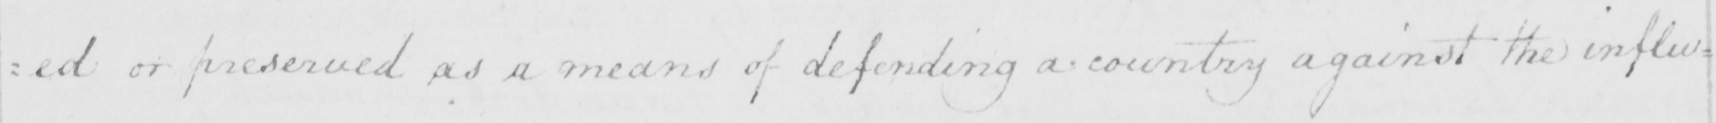What is written in this line of handwriting? : ed or preserved as a means of defending a country against the influ= 